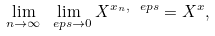<formula> <loc_0><loc_0><loc_500><loc_500>\lim _ { n \to \infty } \lim _ { \ e p s \to 0 } X ^ { x _ { n } , \ e p s } = X ^ { x } ,</formula> 